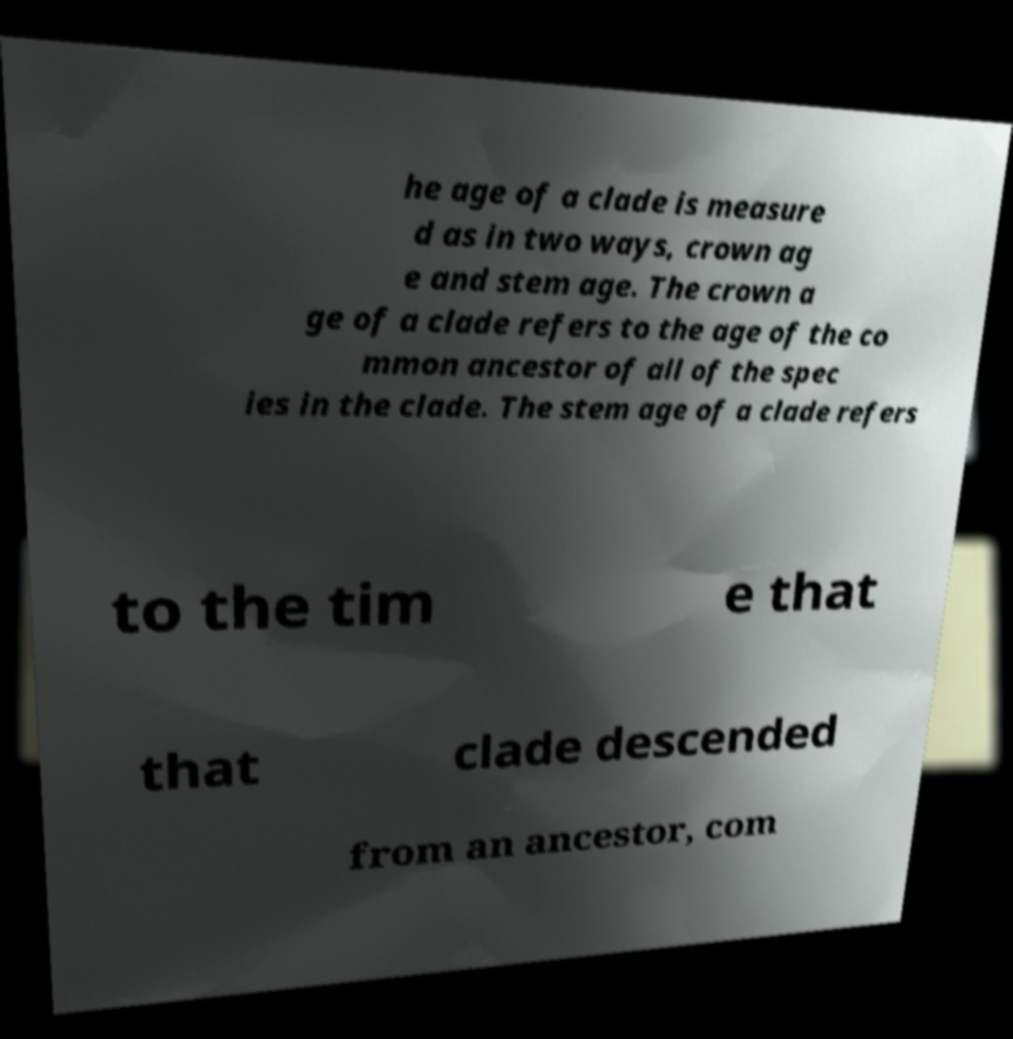Could you assist in decoding the text presented in this image and type it out clearly? he age of a clade is measure d as in two ways, crown ag e and stem age. The crown a ge of a clade refers to the age of the co mmon ancestor of all of the spec ies in the clade. The stem age of a clade refers to the tim e that that clade descended from an ancestor, com 